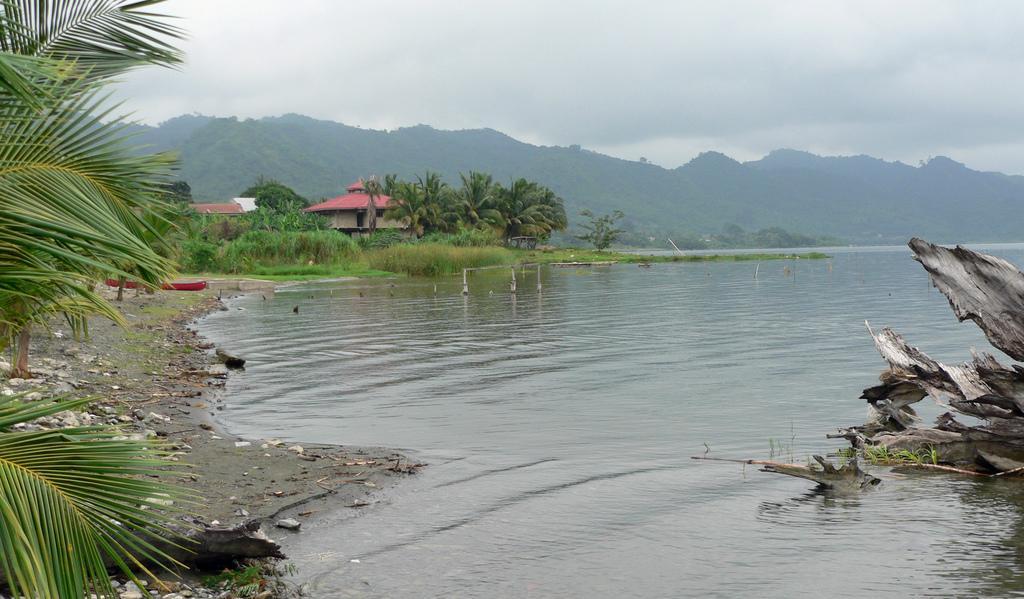Can you describe this image briefly? In the picture we can see a water beside it, we can see some stone particles on the path and some trees and in the background also we can see grass plants. Houses, trees and hills and sky with clouds. 